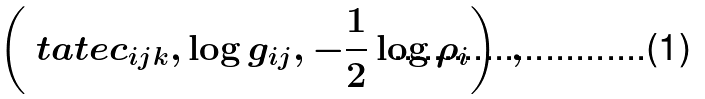<formula> <loc_0><loc_0><loc_500><loc_500>\left ( \ t a t e c _ { i j k } , \log g _ { i j } , - \frac { 1 } { 2 } \log \rho _ { i } \right ) \, ,</formula> 